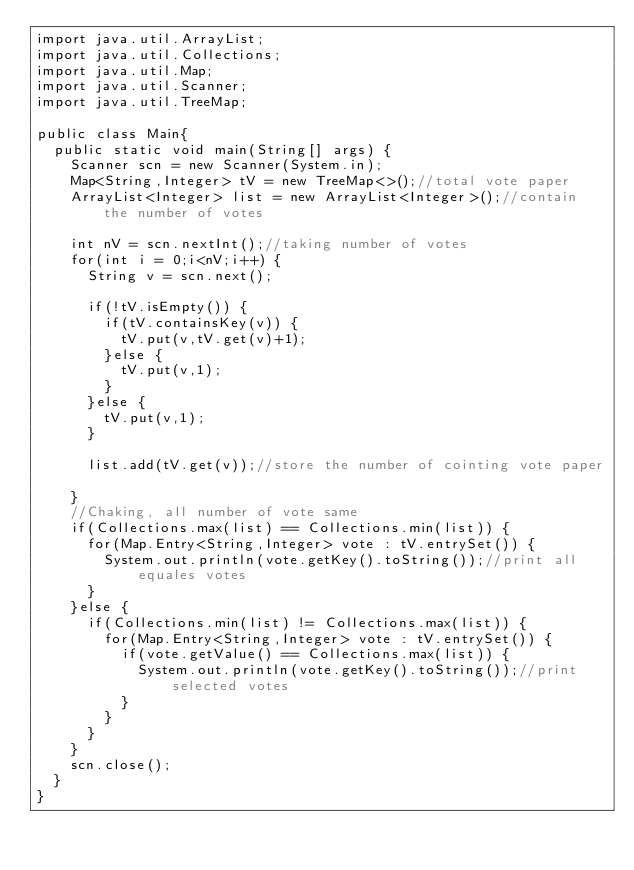<code> <loc_0><loc_0><loc_500><loc_500><_Java_>import java.util.ArrayList;
import java.util.Collections;
import java.util.Map;
import java.util.Scanner;
import java.util.TreeMap;

public class Main{
	public static void main(String[] args) {
		Scanner scn = new Scanner(System.in);
		Map<String,Integer> tV = new TreeMap<>();//total vote paper
		ArrayList<Integer> list = new ArrayList<Integer>();//contain the number of votes
		
		int nV = scn.nextInt();//taking number of votes
		for(int i = 0;i<nV;i++) {
			String v = scn.next();
			
			if(!tV.isEmpty()) {
				if(tV.containsKey(v)) {
					tV.put(v,tV.get(v)+1);
				}else {
					tV.put(v,1);
				}
			}else {
				tV.put(v,1);
			}
			
			list.add(tV.get(v));//store the number of cointing vote paper 
			
		}
		//Chaking, all number of vote same
		if(Collections.max(list) == Collections.min(list)) {
			for(Map.Entry<String,Integer> vote : tV.entrySet()) {
				System.out.println(vote.getKey().toString());//print all equales votes
			}
		}else {
			if(Collections.min(list) != Collections.max(list)) {
				for(Map.Entry<String,Integer> vote : tV.entrySet()) {
					if(vote.getValue() == Collections.max(list)) {
						System.out.println(vote.getKey().toString());//print selected votes
					}
				}
			}
		}
		scn.close();
	}
}</code> 